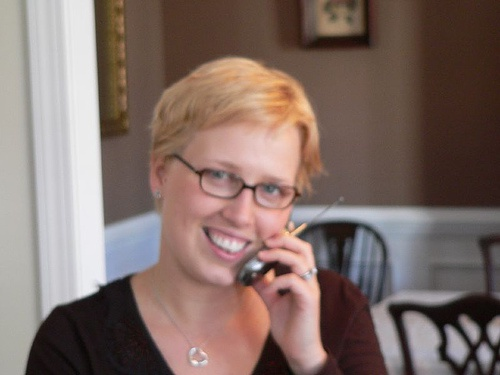Describe the objects in this image and their specific colors. I can see people in darkgray, gray, black, lightpink, and salmon tones, chair in darkgray, black, and gray tones, chair in darkgray, gray, and black tones, dining table in darkgray, gray, and black tones, and cell phone in darkgray, lightpink, gray, black, and brown tones in this image. 